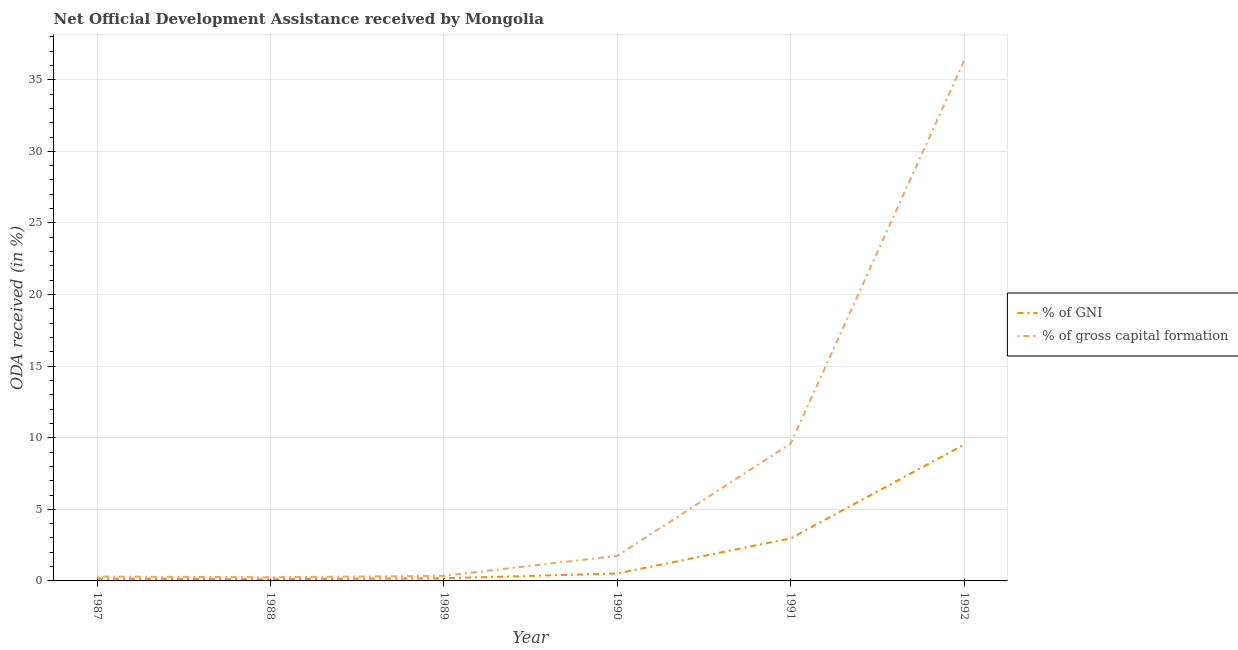What is the oda received as percentage of gross capital formation in 1988?
Give a very brief answer. 0.26. Across all years, what is the maximum oda received as percentage of gross capital formation?
Make the answer very short. 36.32. Across all years, what is the minimum oda received as percentage of gni?
Make the answer very short. 0.12. In which year was the oda received as percentage of gni maximum?
Offer a very short reply. 1992. In which year was the oda received as percentage of gross capital formation minimum?
Your response must be concise. 1988. What is the total oda received as percentage of gni in the graph?
Provide a succinct answer. 13.47. What is the difference between the oda received as percentage of gni in 1988 and that in 1992?
Offer a terse response. -9.39. What is the difference between the oda received as percentage of gross capital formation in 1989 and the oda received as percentage of gni in 1990?
Offer a very short reply. -0.16. What is the average oda received as percentage of gross capital formation per year?
Make the answer very short. 8.1. In the year 1991, what is the difference between the oda received as percentage of gross capital formation and oda received as percentage of gni?
Your response must be concise. 6.61. What is the ratio of the oda received as percentage of gni in 1990 to that in 1992?
Ensure brevity in your answer.  0.05. Is the difference between the oda received as percentage of gni in 1987 and 1991 greater than the difference between the oda received as percentage of gross capital formation in 1987 and 1991?
Ensure brevity in your answer.  Yes. What is the difference between the highest and the second highest oda received as percentage of gross capital formation?
Give a very brief answer. 26.73. What is the difference between the highest and the lowest oda received as percentage of gross capital formation?
Keep it short and to the point. 36.07. Is the oda received as percentage of gross capital formation strictly greater than the oda received as percentage of gni over the years?
Make the answer very short. Yes. How many lines are there?
Your answer should be very brief. 2. How many years are there in the graph?
Your answer should be compact. 6. Are the values on the major ticks of Y-axis written in scientific E-notation?
Ensure brevity in your answer.  No. Where does the legend appear in the graph?
Keep it short and to the point. Center right. How are the legend labels stacked?
Ensure brevity in your answer.  Vertical. What is the title of the graph?
Ensure brevity in your answer.  Net Official Development Assistance received by Mongolia. Does "Fertility rate" appear as one of the legend labels in the graph?
Your answer should be compact. No. What is the label or title of the X-axis?
Provide a succinct answer. Year. What is the label or title of the Y-axis?
Offer a very short reply. ODA received (in %). What is the ODA received (in %) of % of GNI in 1987?
Make the answer very short. 0.16. What is the ODA received (in %) in % of gross capital formation in 1987?
Offer a terse response. 0.3. What is the ODA received (in %) in % of GNI in 1988?
Provide a short and direct response. 0.12. What is the ODA received (in %) of % of gross capital formation in 1988?
Offer a very short reply. 0.26. What is the ODA received (in %) in % of GNI in 1989?
Your answer should be very brief. 0.19. What is the ODA received (in %) of % of gross capital formation in 1989?
Ensure brevity in your answer.  0.36. What is the ODA received (in %) in % of GNI in 1990?
Your response must be concise. 0.52. What is the ODA received (in %) of % of gross capital formation in 1990?
Give a very brief answer. 1.75. What is the ODA received (in %) in % of GNI in 1991?
Ensure brevity in your answer.  2.98. What is the ODA received (in %) of % of gross capital formation in 1991?
Your answer should be compact. 9.59. What is the ODA received (in %) of % of GNI in 1992?
Keep it short and to the point. 9.51. What is the ODA received (in %) of % of gross capital formation in 1992?
Ensure brevity in your answer.  36.32. Across all years, what is the maximum ODA received (in %) in % of GNI?
Offer a terse response. 9.51. Across all years, what is the maximum ODA received (in %) in % of gross capital formation?
Offer a terse response. 36.32. Across all years, what is the minimum ODA received (in %) of % of GNI?
Provide a succinct answer. 0.12. Across all years, what is the minimum ODA received (in %) in % of gross capital formation?
Your response must be concise. 0.26. What is the total ODA received (in %) of % of GNI in the graph?
Make the answer very short. 13.47. What is the total ODA received (in %) in % of gross capital formation in the graph?
Your answer should be compact. 48.58. What is the difference between the ODA received (in %) of % of GNI in 1987 and that in 1988?
Keep it short and to the point. 0.03. What is the difference between the ODA received (in %) in % of gross capital formation in 1987 and that in 1988?
Offer a terse response. 0.05. What is the difference between the ODA received (in %) of % of GNI in 1987 and that in 1989?
Your answer should be very brief. -0.03. What is the difference between the ODA received (in %) of % of gross capital formation in 1987 and that in 1989?
Offer a terse response. -0.05. What is the difference between the ODA received (in %) of % of GNI in 1987 and that in 1990?
Your answer should be compact. -0.36. What is the difference between the ODA received (in %) in % of gross capital formation in 1987 and that in 1990?
Offer a very short reply. -1.45. What is the difference between the ODA received (in %) in % of GNI in 1987 and that in 1991?
Your response must be concise. -2.82. What is the difference between the ODA received (in %) of % of gross capital formation in 1987 and that in 1991?
Give a very brief answer. -9.28. What is the difference between the ODA received (in %) in % of GNI in 1987 and that in 1992?
Your response must be concise. -9.36. What is the difference between the ODA received (in %) in % of gross capital formation in 1987 and that in 1992?
Provide a succinct answer. -36.02. What is the difference between the ODA received (in %) of % of GNI in 1988 and that in 1989?
Your answer should be compact. -0.06. What is the difference between the ODA received (in %) of % of gross capital formation in 1988 and that in 1989?
Your answer should be compact. -0.1. What is the difference between the ODA received (in %) in % of GNI in 1988 and that in 1990?
Give a very brief answer. -0.4. What is the difference between the ODA received (in %) in % of gross capital formation in 1988 and that in 1990?
Offer a very short reply. -1.5. What is the difference between the ODA received (in %) of % of GNI in 1988 and that in 1991?
Make the answer very short. -2.85. What is the difference between the ODA received (in %) of % of gross capital formation in 1988 and that in 1991?
Give a very brief answer. -9.33. What is the difference between the ODA received (in %) of % of GNI in 1988 and that in 1992?
Ensure brevity in your answer.  -9.39. What is the difference between the ODA received (in %) in % of gross capital formation in 1988 and that in 1992?
Provide a short and direct response. -36.07. What is the difference between the ODA received (in %) in % of gross capital formation in 1989 and that in 1990?
Offer a terse response. -1.4. What is the difference between the ODA received (in %) of % of GNI in 1989 and that in 1991?
Provide a short and direct response. -2.79. What is the difference between the ODA received (in %) of % of gross capital formation in 1989 and that in 1991?
Provide a short and direct response. -9.23. What is the difference between the ODA received (in %) in % of GNI in 1989 and that in 1992?
Your answer should be very brief. -9.33. What is the difference between the ODA received (in %) of % of gross capital formation in 1989 and that in 1992?
Provide a succinct answer. -35.97. What is the difference between the ODA received (in %) of % of GNI in 1990 and that in 1991?
Provide a succinct answer. -2.46. What is the difference between the ODA received (in %) in % of gross capital formation in 1990 and that in 1991?
Make the answer very short. -7.84. What is the difference between the ODA received (in %) of % of GNI in 1990 and that in 1992?
Offer a terse response. -8.99. What is the difference between the ODA received (in %) in % of gross capital formation in 1990 and that in 1992?
Keep it short and to the point. -34.57. What is the difference between the ODA received (in %) of % of GNI in 1991 and that in 1992?
Ensure brevity in your answer.  -6.54. What is the difference between the ODA received (in %) in % of gross capital formation in 1991 and that in 1992?
Offer a very short reply. -26.73. What is the difference between the ODA received (in %) in % of GNI in 1987 and the ODA received (in %) in % of gross capital formation in 1988?
Ensure brevity in your answer.  -0.1. What is the difference between the ODA received (in %) in % of GNI in 1987 and the ODA received (in %) in % of gross capital formation in 1989?
Offer a very short reply. -0.2. What is the difference between the ODA received (in %) of % of GNI in 1987 and the ODA received (in %) of % of gross capital formation in 1990?
Make the answer very short. -1.6. What is the difference between the ODA received (in %) of % of GNI in 1987 and the ODA received (in %) of % of gross capital formation in 1991?
Make the answer very short. -9.43. What is the difference between the ODA received (in %) in % of GNI in 1987 and the ODA received (in %) in % of gross capital formation in 1992?
Give a very brief answer. -36.17. What is the difference between the ODA received (in %) in % of GNI in 1988 and the ODA received (in %) in % of gross capital formation in 1989?
Provide a short and direct response. -0.24. What is the difference between the ODA received (in %) in % of GNI in 1988 and the ODA received (in %) in % of gross capital formation in 1990?
Keep it short and to the point. -1.63. What is the difference between the ODA received (in %) of % of GNI in 1988 and the ODA received (in %) of % of gross capital formation in 1991?
Offer a terse response. -9.47. What is the difference between the ODA received (in %) of % of GNI in 1988 and the ODA received (in %) of % of gross capital formation in 1992?
Offer a terse response. -36.2. What is the difference between the ODA received (in %) of % of GNI in 1989 and the ODA received (in %) of % of gross capital formation in 1990?
Keep it short and to the point. -1.57. What is the difference between the ODA received (in %) in % of GNI in 1989 and the ODA received (in %) in % of gross capital formation in 1991?
Give a very brief answer. -9.4. What is the difference between the ODA received (in %) in % of GNI in 1989 and the ODA received (in %) in % of gross capital formation in 1992?
Provide a succinct answer. -36.14. What is the difference between the ODA received (in %) of % of GNI in 1990 and the ODA received (in %) of % of gross capital formation in 1991?
Provide a short and direct response. -9.07. What is the difference between the ODA received (in %) of % of GNI in 1990 and the ODA received (in %) of % of gross capital formation in 1992?
Ensure brevity in your answer.  -35.8. What is the difference between the ODA received (in %) of % of GNI in 1991 and the ODA received (in %) of % of gross capital formation in 1992?
Your answer should be very brief. -33.35. What is the average ODA received (in %) of % of GNI per year?
Offer a very short reply. 2.24. What is the average ODA received (in %) of % of gross capital formation per year?
Make the answer very short. 8.1. In the year 1987, what is the difference between the ODA received (in %) in % of GNI and ODA received (in %) in % of gross capital formation?
Your response must be concise. -0.15. In the year 1988, what is the difference between the ODA received (in %) of % of GNI and ODA received (in %) of % of gross capital formation?
Provide a succinct answer. -0.13. In the year 1989, what is the difference between the ODA received (in %) of % of GNI and ODA received (in %) of % of gross capital formation?
Give a very brief answer. -0.17. In the year 1990, what is the difference between the ODA received (in %) in % of GNI and ODA received (in %) in % of gross capital formation?
Your response must be concise. -1.23. In the year 1991, what is the difference between the ODA received (in %) in % of GNI and ODA received (in %) in % of gross capital formation?
Make the answer very short. -6.61. In the year 1992, what is the difference between the ODA received (in %) in % of GNI and ODA received (in %) in % of gross capital formation?
Give a very brief answer. -26.81. What is the ratio of the ODA received (in %) in % of GNI in 1987 to that in 1988?
Make the answer very short. 1.29. What is the ratio of the ODA received (in %) of % of gross capital formation in 1987 to that in 1988?
Make the answer very short. 1.19. What is the ratio of the ODA received (in %) in % of GNI in 1987 to that in 1989?
Your answer should be very brief. 0.84. What is the ratio of the ODA received (in %) in % of gross capital formation in 1987 to that in 1989?
Offer a very short reply. 0.86. What is the ratio of the ODA received (in %) in % of gross capital formation in 1987 to that in 1990?
Offer a very short reply. 0.17. What is the ratio of the ODA received (in %) of % of GNI in 1987 to that in 1991?
Your answer should be very brief. 0.05. What is the ratio of the ODA received (in %) in % of gross capital formation in 1987 to that in 1991?
Provide a succinct answer. 0.03. What is the ratio of the ODA received (in %) of % of GNI in 1987 to that in 1992?
Your answer should be compact. 0.02. What is the ratio of the ODA received (in %) in % of gross capital formation in 1987 to that in 1992?
Your answer should be very brief. 0.01. What is the ratio of the ODA received (in %) of % of GNI in 1988 to that in 1989?
Provide a succinct answer. 0.65. What is the ratio of the ODA received (in %) in % of gross capital formation in 1988 to that in 1989?
Keep it short and to the point. 0.72. What is the ratio of the ODA received (in %) in % of GNI in 1988 to that in 1990?
Provide a succinct answer. 0.23. What is the ratio of the ODA received (in %) in % of gross capital formation in 1988 to that in 1990?
Provide a succinct answer. 0.15. What is the ratio of the ODA received (in %) in % of GNI in 1988 to that in 1991?
Your answer should be very brief. 0.04. What is the ratio of the ODA received (in %) in % of gross capital formation in 1988 to that in 1991?
Keep it short and to the point. 0.03. What is the ratio of the ODA received (in %) of % of GNI in 1988 to that in 1992?
Keep it short and to the point. 0.01. What is the ratio of the ODA received (in %) of % of gross capital formation in 1988 to that in 1992?
Your answer should be compact. 0.01. What is the ratio of the ODA received (in %) of % of GNI in 1989 to that in 1990?
Your answer should be very brief. 0.36. What is the ratio of the ODA received (in %) in % of gross capital formation in 1989 to that in 1990?
Ensure brevity in your answer.  0.2. What is the ratio of the ODA received (in %) in % of GNI in 1989 to that in 1991?
Offer a very short reply. 0.06. What is the ratio of the ODA received (in %) of % of gross capital formation in 1989 to that in 1991?
Your answer should be very brief. 0.04. What is the ratio of the ODA received (in %) of % of GNI in 1989 to that in 1992?
Provide a succinct answer. 0.02. What is the ratio of the ODA received (in %) of % of gross capital formation in 1989 to that in 1992?
Make the answer very short. 0.01. What is the ratio of the ODA received (in %) of % of GNI in 1990 to that in 1991?
Give a very brief answer. 0.17. What is the ratio of the ODA received (in %) of % of gross capital formation in 1990 to that in 1991?
Your response must be concise. 0.18. What is the ratio of the ODA received (in %) of % of GNI in 1990 to that in 1992?
Your answer should be compact. 0.05. What is the ratio of the ODA received (in %) in % of gross capital formation in 1990 to that in 1992?
Make the answer very short. 0.05. What is the ratio of the ODA received (in %) of % of GNI in 1991 to that in 1992?
Provide a succinct answer. 0.31. What is the ratio of the ODA received (in %) in % of gross capital formation in 1991 to that in 1992?
Give a very brief answer. 0.26. What is the difference between the highest and the second highest ODA received (in %) of % of GNI?
Make the answer very short. 6.54. What is the difference between the highest and the second highest ODA received (in %) of % of gross capital formation?
Keep it short and to the point. 26.73. What is the difference between the highest and the lowest ODA received (in %) of % of GNI?
Your answer should be compact. 9.39. What is the difference between the highest and the lowest ODA received (in %) of % of gross capital formation?
Offer a terse response. 36.07. 